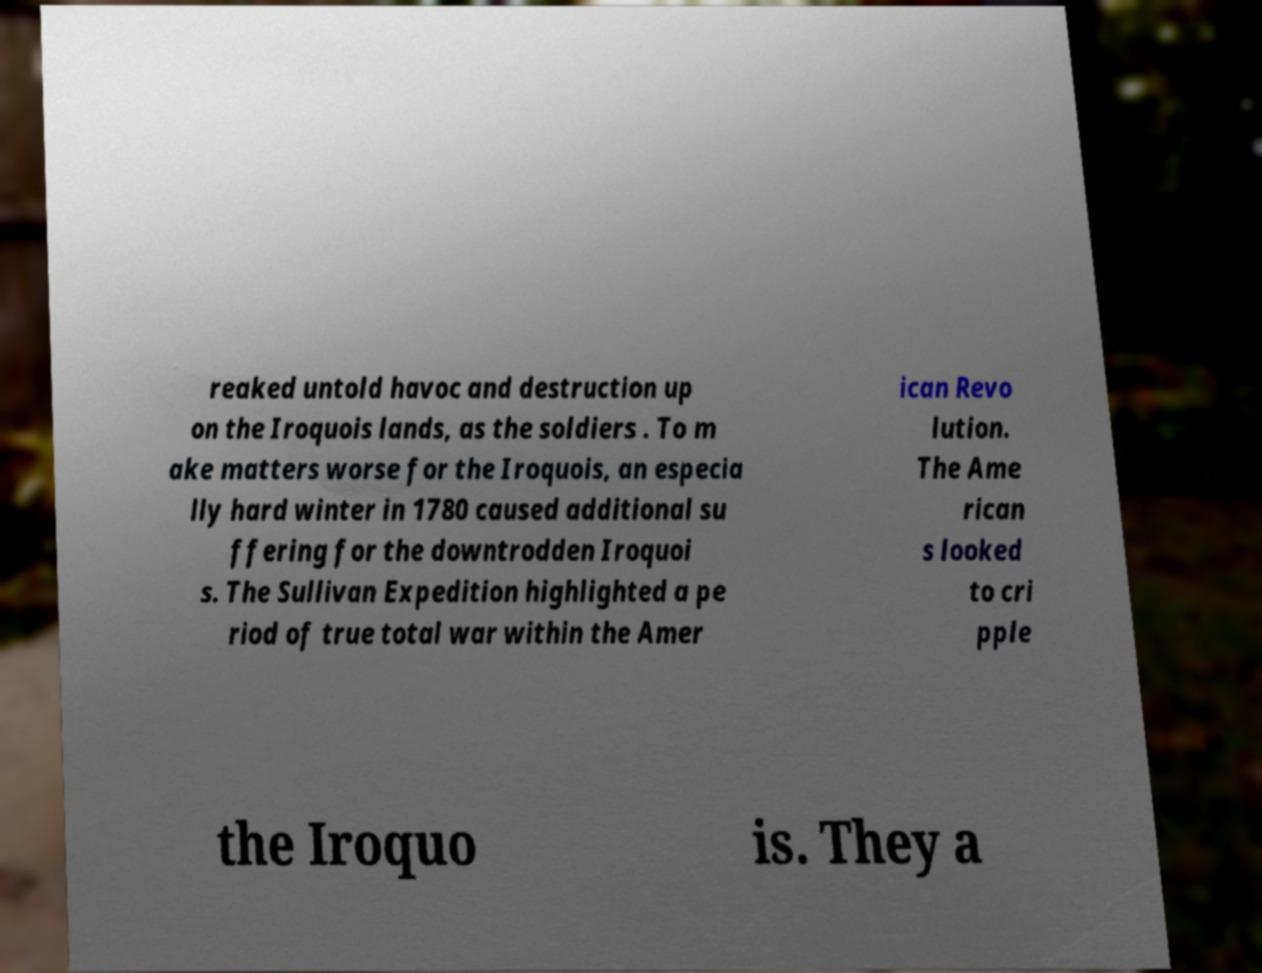Could you assist in decoding the text presented in this image and type it out clearly? reaked untold havoc and destruction up on the Iroquois lands, as the soldiers . To m ake matters worse for the Iroquois, an especia lly hard winter in 1780 caused additional su ffering for the downtrodden Iroquoi s. The Sullivan Expedition highlighted a pe riod of true total war within the Amer ican Revo lution. The Ame rican s looked to cri pple the Iroquo is. They a 